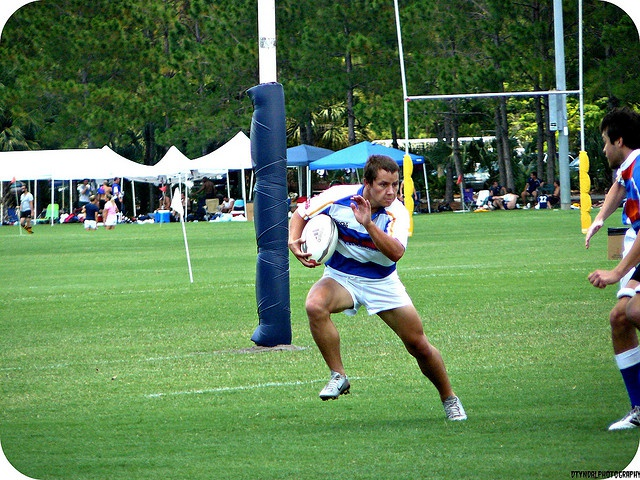Describe the objects in this image and their specific colors. I can see people in white, black, gray, and maroon tones, people in white, black, gray, and navy tones, people in white, black, gray, and maroon tones, sports ball in white, darkgray, gray, and lightblue tones, and bus in white, darkgray, beige, and gray tones in this image. 